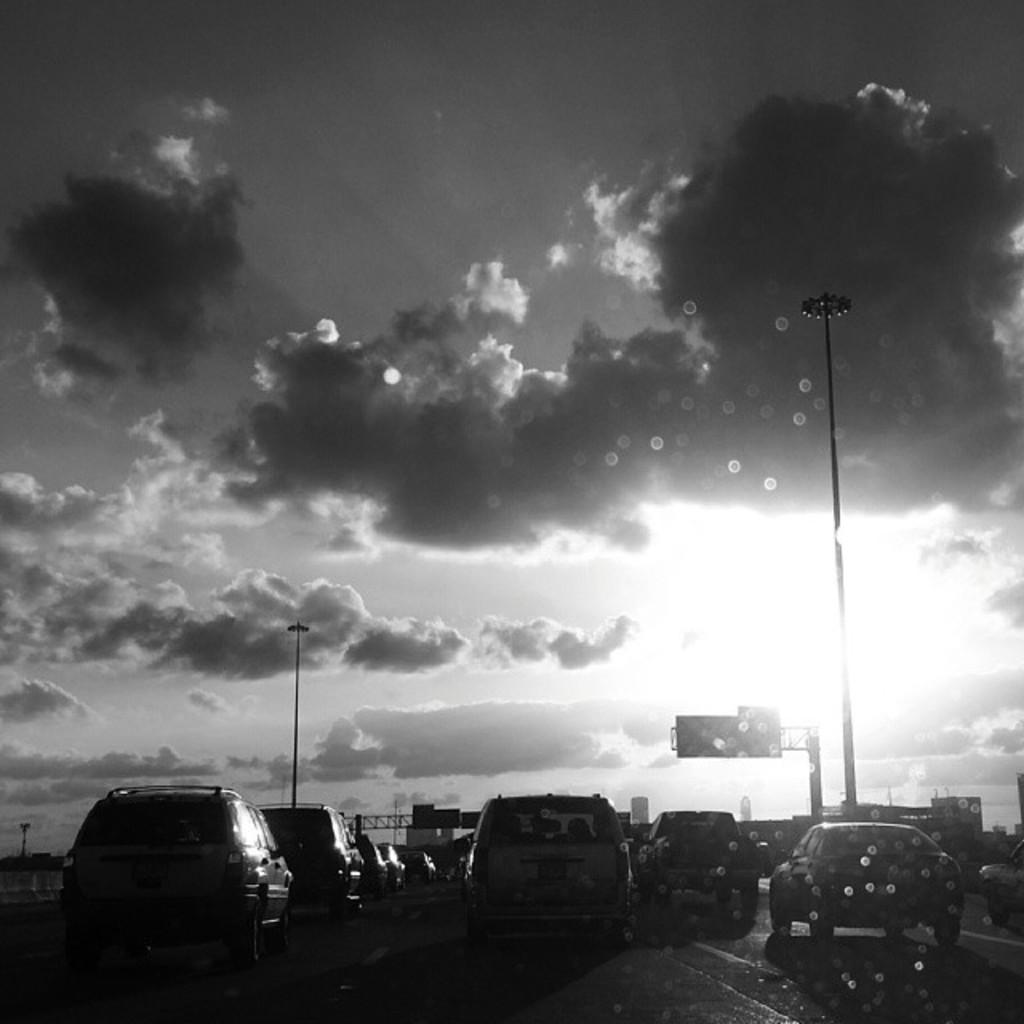What is happening on the road in the image? There are cars moving on the road in the image. What can be seen beside the road in the image? There are poles beside the road in the image. What is the condition of the sky in the image? The sky is full of clouds in the image. What type of pain is the driver experiencing while driving in the image? There is no indication of any pain experienced by the driver in the image. How does the image capture the attention of the viewer? The image captures the viewer's attention by showing cars moving on the road and the presence of poles and clouds. 